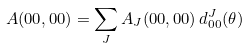<formula> <loc_0><loc_0><loc_500><loc_500>A ( 0 0 , 0 0 ) = \sum _ { J } A _ { J } ( 0 0 , 0 0 ) \, d _ { 0 0 } ^ { J } ( \theta )</formula> 